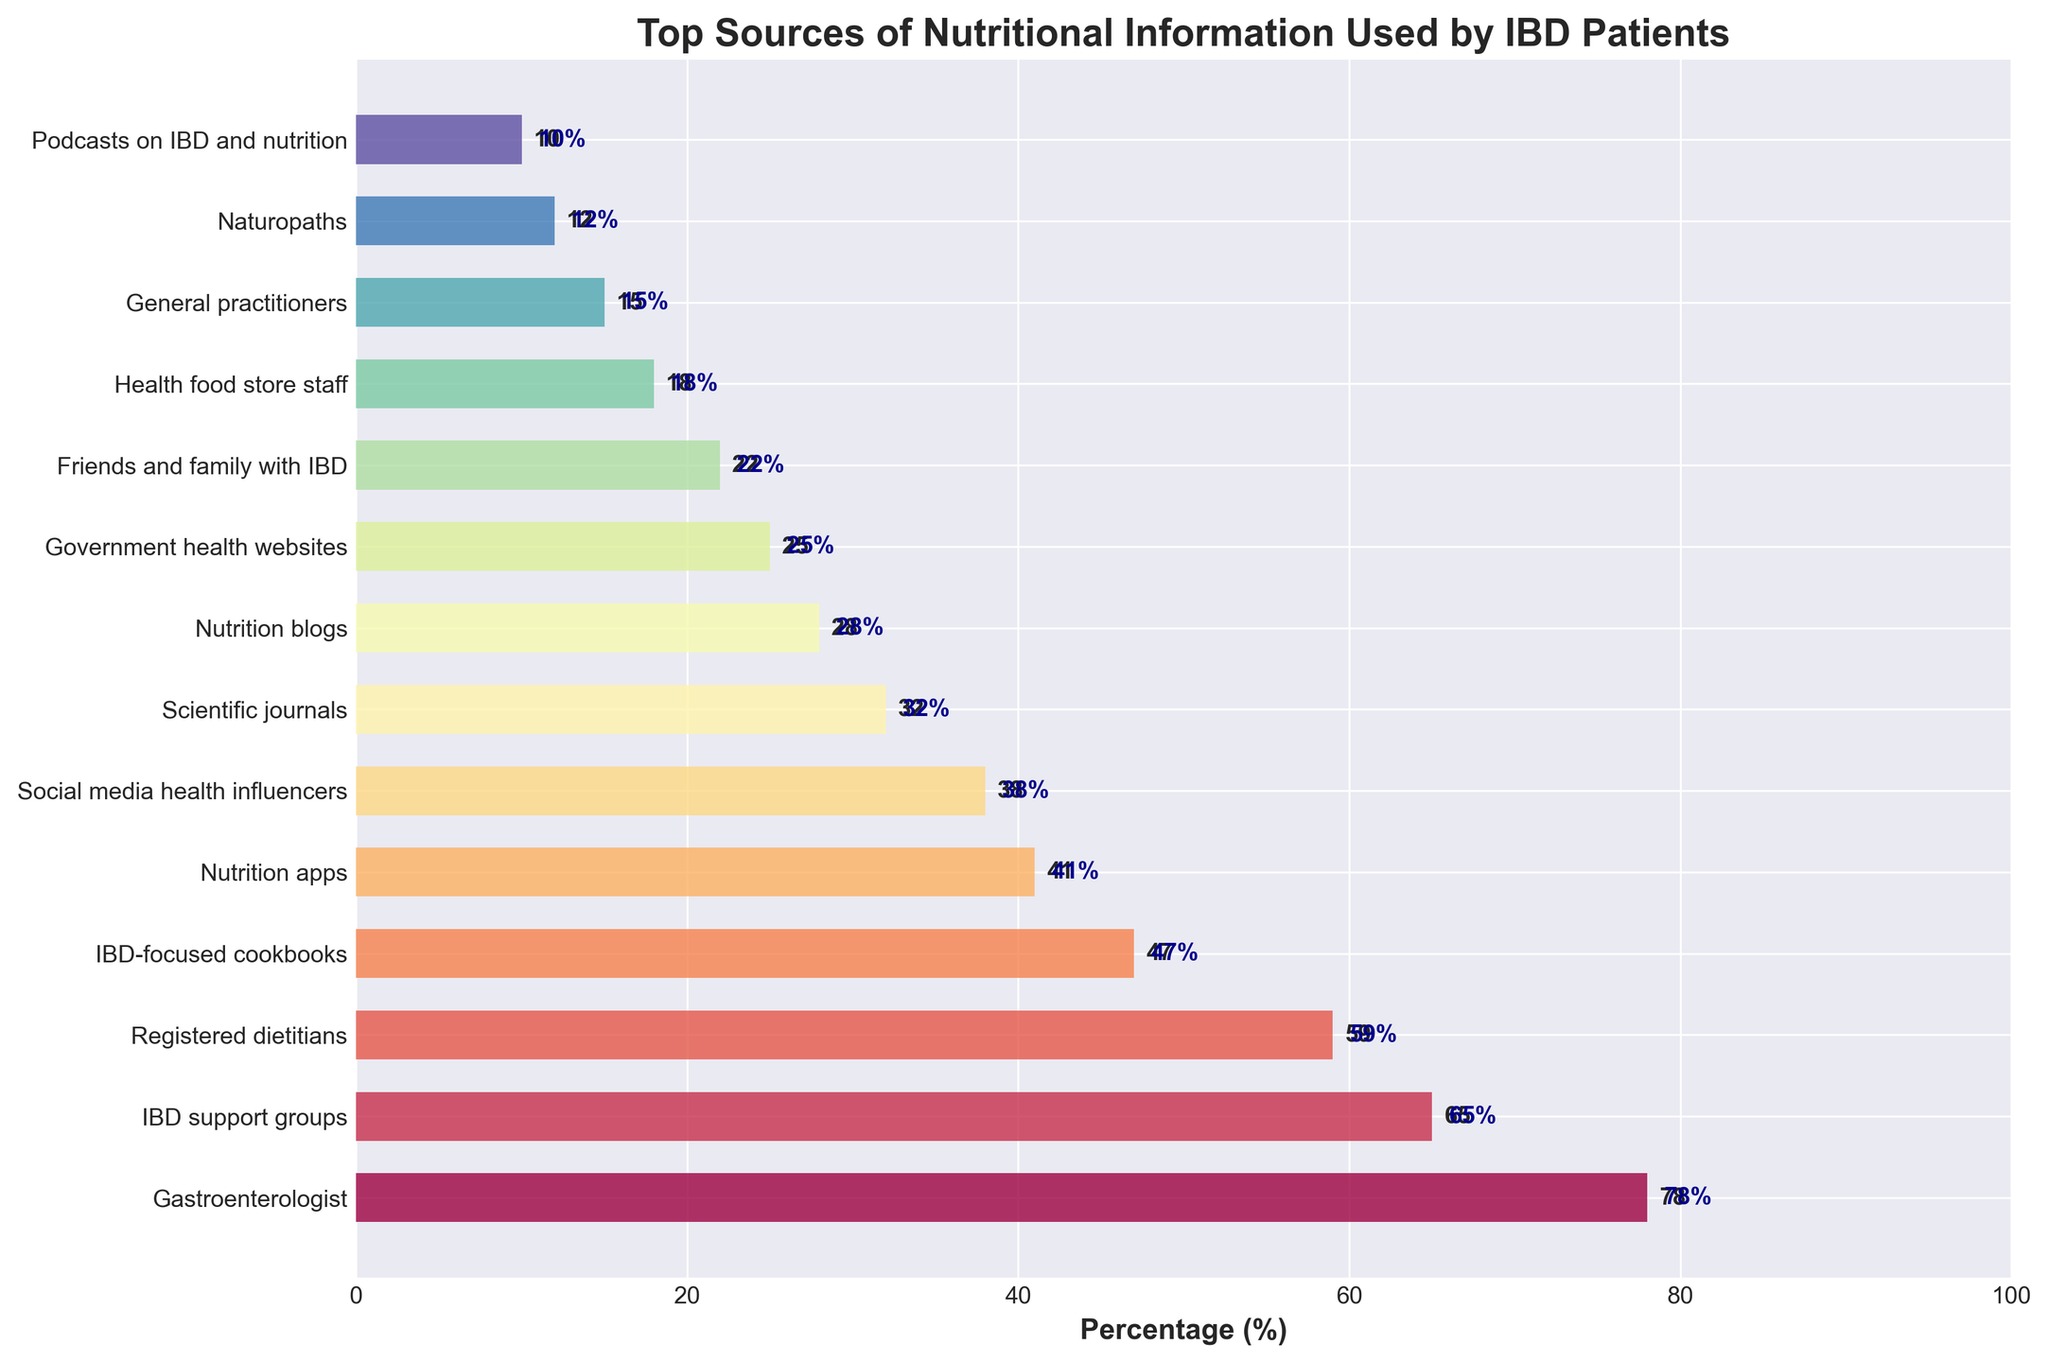What's the most popular source of nutritional information among IBD patients? The figure shows a ranked list of sources, with percentages next to each source indicating their popularity. The most popular source is at the top of the list.
Answer: Gastroenterologist What is the difference in usage percentage between Registered Dietitians and Nutrition Apps? From the figure, the percentage for Registered Dietitians is 59% and for Nutrition Apps is 41%. The difference is calculated by subtracting the smaller percentage from the larger one, i.e., 59% - 41%.
Answer: 18% Which source has a higher usage, Scientific Journals or Social Media Health Influencers? By comparing the bars' lengths and their percentages, Scientific Journals stand at 32% and Social Media Health Influencers at 38%. Since 38% is greater than 32%, Social Media Health Influencers have higher usage.
Answer: Social Media Health Influencers Is the usage percentage for General Practitioners higher than Friends and Family with IBD? According to the figure, Friends and Family with IBD have a usage percentage of 22%, whereas General Practitioners have 15%. Since 22% is greater than 15%, the usage for General Practitioners is not higher.
Answer: No How much more popular are IBD Support Groups compared to Podcasts on IBD and Nutrition? The figure shows that IBD Support Groups have a popularity of 65% and Podcasts on IBD and Nutrition have 10%. The difference is calculated as 65% - 10%.
Answer: 55% What's the combined usage percentage for the top three sources? The percentage for Gastroenterologists is 78%, IBD Support Groups is 65%, and Registered Dietitians is 59%. Adding these percentages gives 78% + 65% + 59%.
Answer: 202% What is the median usage percentage of all sources listed? To find the median, first, list all the percentages in ascending order: 10, 12, 15, 18, 22, 25, 28, 32, 38, 41, 47, 59, 65, 78. Since there are 14 values, the median is the average of the 7th and 8th values: (28 + 32) / 2.
Answer: 30% Which source has a shorter bar length, Naturopaths or Health Food Store Staff, and what does it indicate? The figure shows that Naturopaths have a usage percentage of 12%, whereas Health Food Store Staff have 18%. Since 12% is less than 18%, Naturopaths have a shorter bar, indicating a lower usage percentage.
Answer: Naturopaths Are there more sources with a usage percentage of 50% or higher, or below 50%? From the figure, count the sources with percentages 50% or higher: Gastroenterologists (78%), IBD Support Groups (65%), Registered Dietitians (59%)—3 sources. Count the sources with percentages below 50%: All others—11 sources. More sources are below 50%.
Answer: Below 50% 